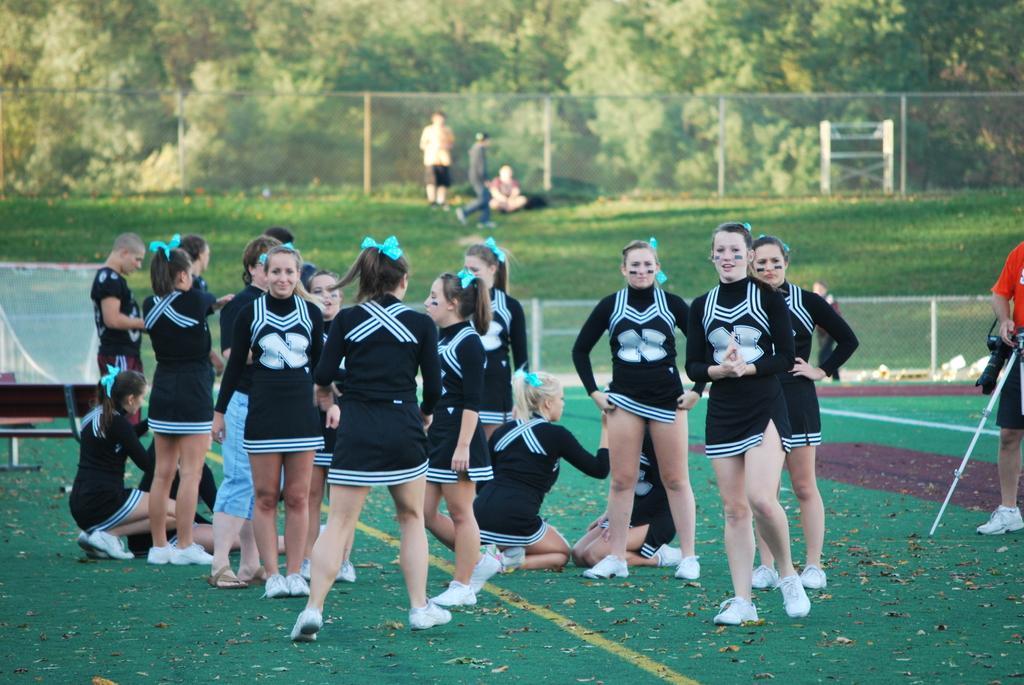Could you give a brief overview of what you see in this image? A group of beautiful girls are standing in the ground, they wore black color dresses. In the long back side there are green color dresses. 